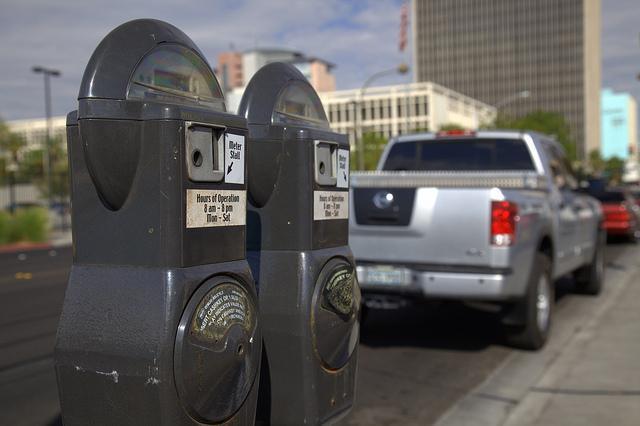What is the purpose of the object?
Pick the correct solution from the four options below to address the question.
Options: Call police, call ambulance, help you, provide parking. Provide parking. 